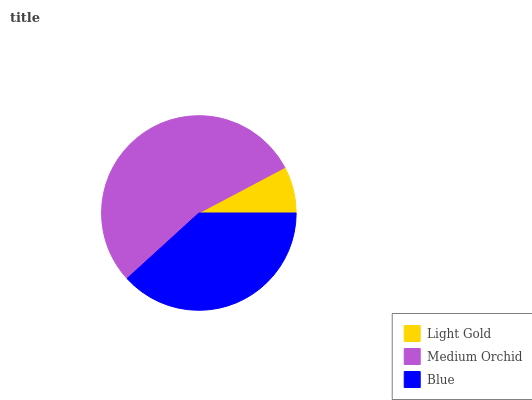Is Light Gold the minimum?
Answer yes or no. Yes. Is Medium Orchid the maximum?
Answer yes or no. Yes. Is Blue the minimum?
Answer yes or no. No. Is Blue the maximum?
Answer yes or no. No. Is Medium Orchid greater than Blue?
Answer yes or no. Yes. Is Blue less than Medium Orchid?
Answer yes or no. Yes. Is Blue greater than Medium Orchid?
Answer yes or no. No. Is Medium Orchid less than Blue?
Answer yes or no. No. Is Blue the high median?
Answer yes or no. Yes. Is Blue the low median?
Answer yes or no. Yes. Is Light Gold the high median?
Answer yes or no. No. Is Light Gold the low median?
Answer yes or no. No. 